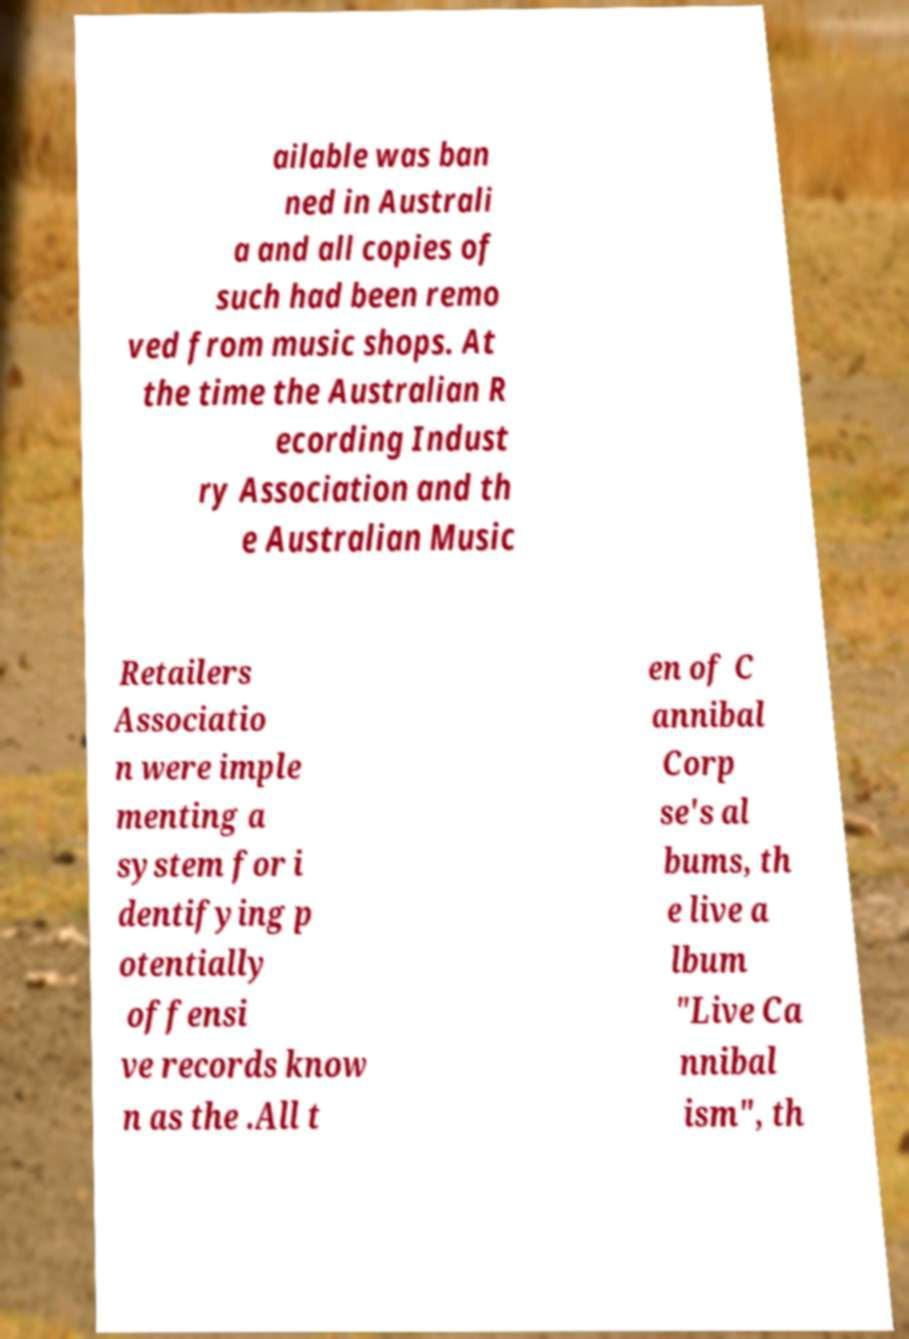Please identify and transcribe the text found in this image. ailable was ban ned in Australi a and all copies of such had been remo ved from music shops. At the time the Australian R ecording Indust ry Association and th e Australian Music Retailers Associatio n were imple menting a system for i dentifying p otentially offensi ve records know n as the .All t en of C annibal Corp se's al bums, th e live a lbum "Live Ca nnibal ism", th 